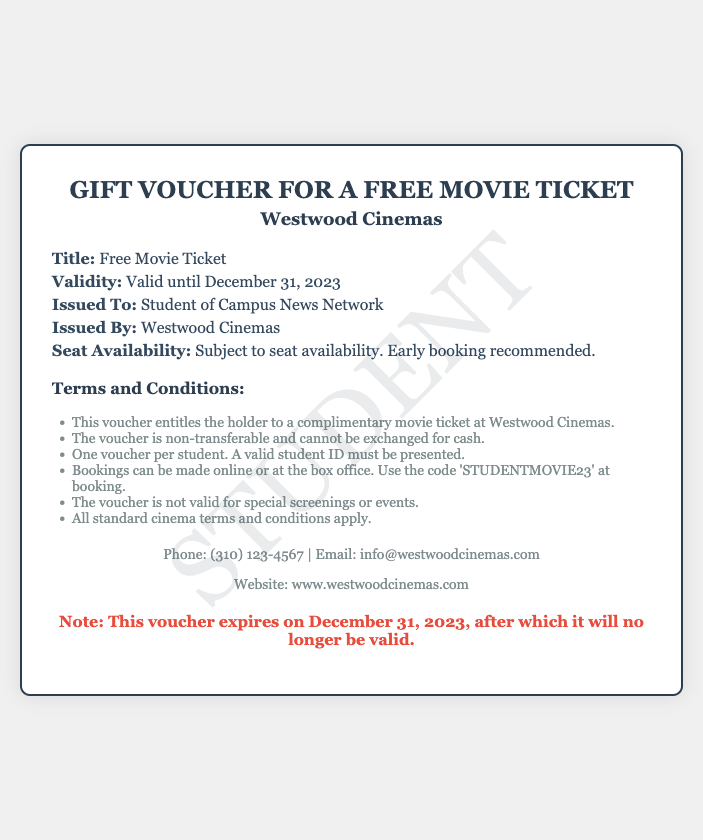What is the title of the voucher? The title is specified in the document as "Free Movie Ticket."
Answer: Free Movie Ticket Who issued the gift voucher? The issuer of the voucher is mentioned in the document as "Westwood Cinemas."
Answer: Westwood Cinemas What is the validity date of the voucher? The document states that the voucher is valid until December 31, 2023.
Answer: December 31, 2023 What must be presented to use the voucher? The document indicates that a valid student ID must be presented.
Answer: Valid student ID Is the voucher transferable? The terms state that the voucher is non-transferable.
Answer: Non-transferable What code should be used at booking? The document specifies the use of the code 'STUDENTMOVIE23' at booking.
Answer: STUDENTMOVIE23 When does the voucher expire? The expiration of the voucher is noted to be on December 31, 2023.
Answer: December 31, 2023 How many vouchers can one student use? The document states that only one voucher per student is allowed.
Answer: One voucher per student What is recommended for seat availability? The document recommends early booking for seat availability.
Answer: Early booking recommended 